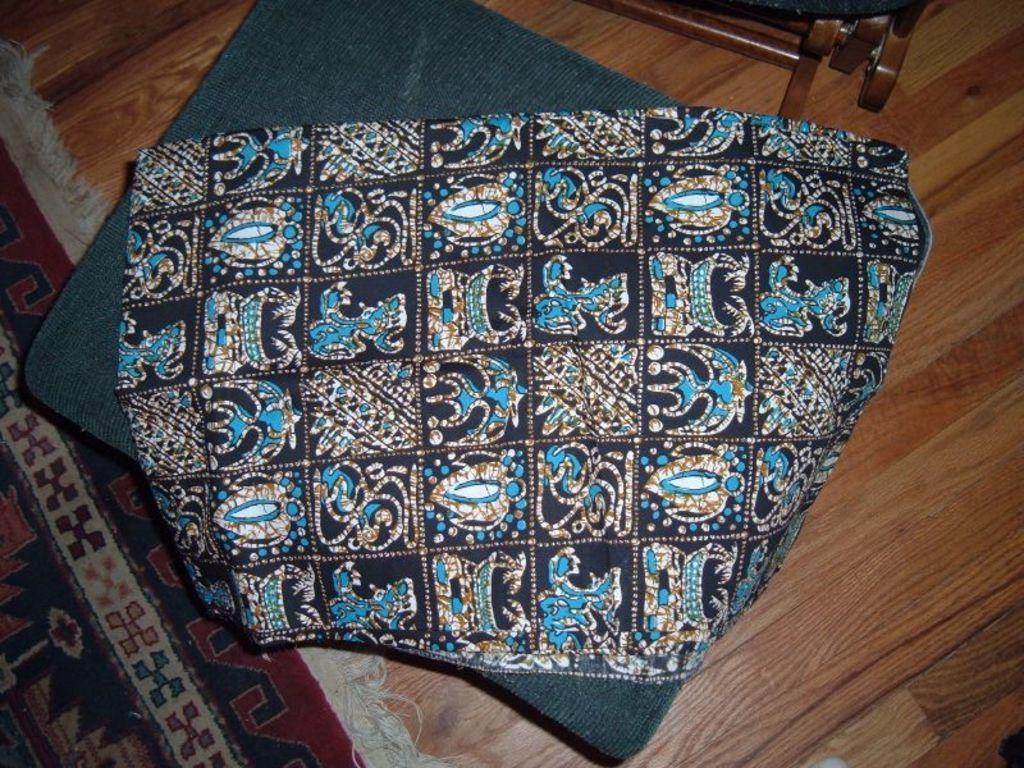What is present on an unspecified object in the image? There is a cloth on an unspecified object in the image. What else can be seen on the floor in the image? There is a floor mat in the image. What type of twig can be seen on the cloth in the image? There is no twig present on the cloth in the image. What is the taste of the cloth in the image? Cloth does not have a taste, as it is not an edible item. 